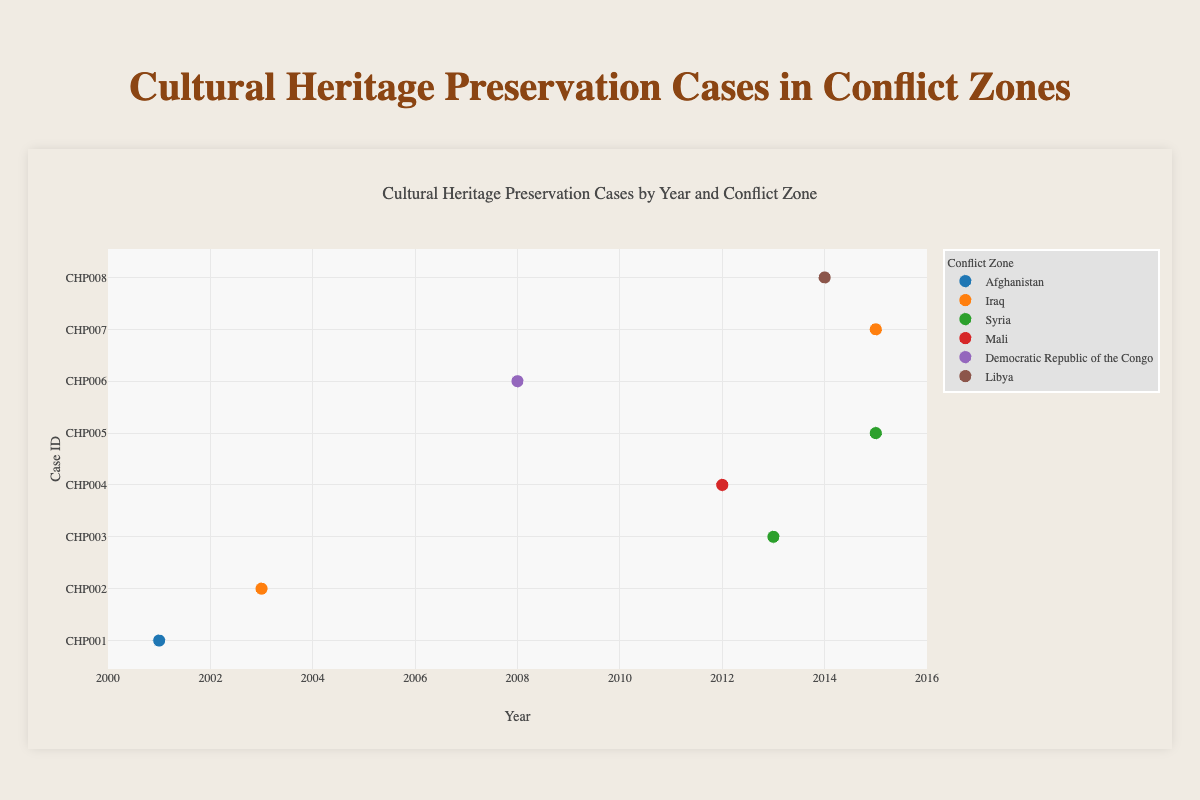What's the title of the figure? The title is located at the top of the chart and is clearly marked. It provides a summary of what the chart is about.
Answer: Cultural Heritage Preservation Cases by Year and Conflict Zone What years do the data points span? By looking at the x-axis, which represents the years, we can see that the data points range from the early 2000s to the mid-2010s.
Answer: 2001 to 2015 Which conflict zone has the highest number of cases represented? By counting the data points (markers) for each conflict zone in the legend, we can identify which zone has the most cases. Syria has 2 data points while other zones have 1 each.
Answer: Syria What's the ruling for the case from Afghanistan? By hovering over the data point labeled "Afghanistan" and looking at the tooltip, it shows the detailed information of the case including the ruling.
Answer: Condemnation by UNESCO How many cases were there in 2015? By checking the x-axis at the year 2015, we count the data points aligned with that year. There are two data points (one for Syria and one for Iraq).
Answer: 2 Which conflict zone had a case ruled by "ICC Conviction of Al Mahdi"? By examining the tooltips of the data points until we find the ruling "ICC Conviction of Al Mahdi," we can see that it belongs to Mali.
Answer: Mali Are there more cases before or after 2010? Count the number of data points to the left (before) and right (after) of the year 2010 on the x-axis. There are three data points before 2010 and five after.
Answer: More after 2010 Which year had the most significant concentration of cases? By identifying the year with the highest number of data points on the x-axis, we find that 2015 has the most data points.
Answer: 2015 What's the latest year represented in the cases from Syria? By looking at the x-axis for the data points labeled "Syria," we identify the latest year.
Answer: 2015 